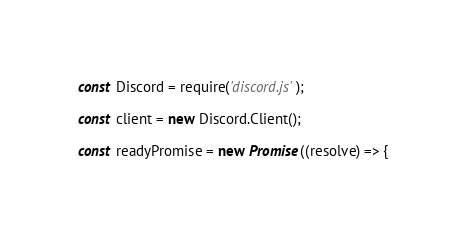<code> <loc_0><loc_0><loc_500><loc_500><_JavaScript_>const Discord = require('discord.js');

const client = new Discord.Client();

const readyPromise = new Promise((resolve) => {</code> 